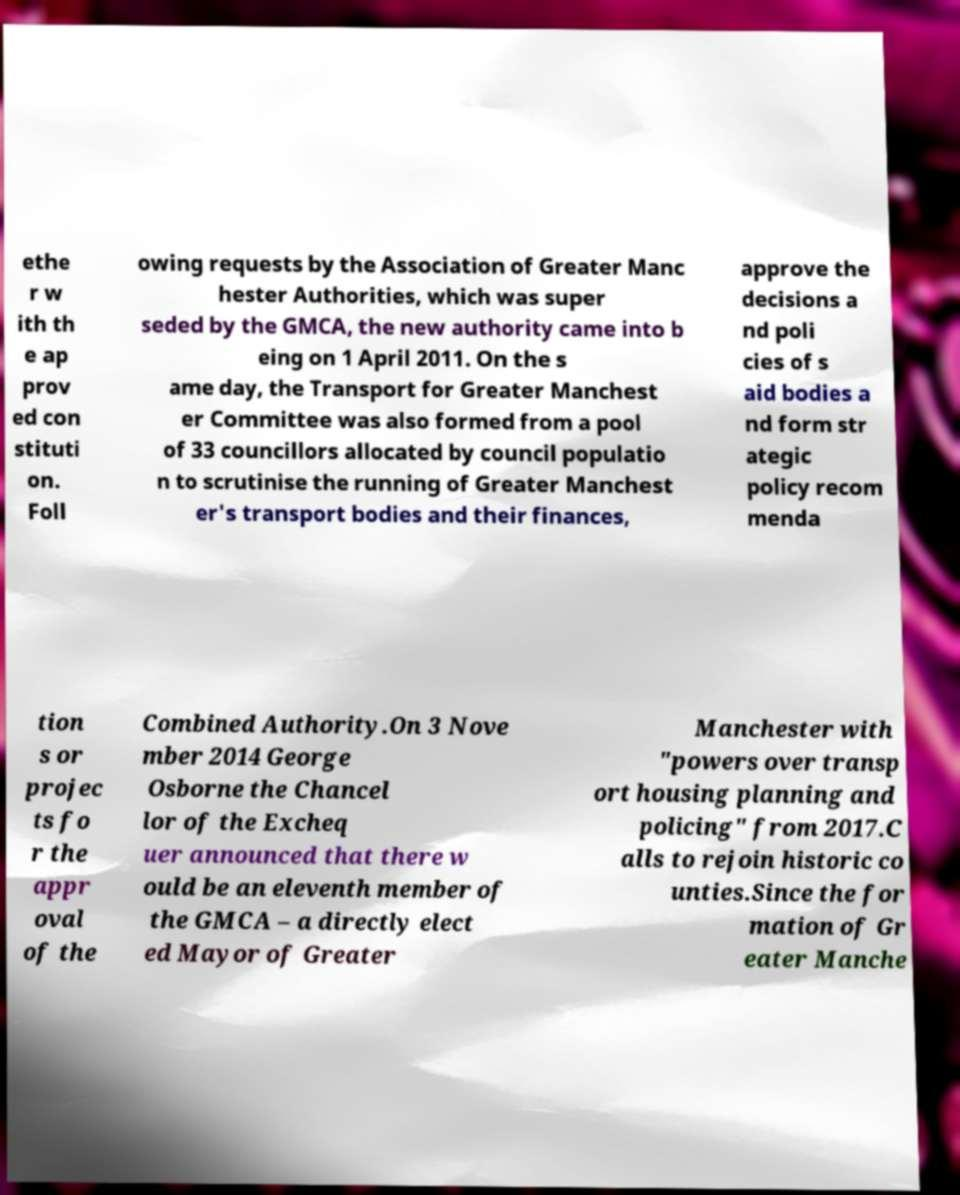For documentation purposes, I need the text within this image transcribed. Could you provide that? ethe r w ith th e ap prov ed con stituti on. Foll owing requests by the Association of Greater Manc hester Authorities, which was super seded by the GMCA, the new authority came into b eing on 1 April 2011. On the s ame day, the Transport for Greater Manchest er Committee was also formed from a pool of 33 councillors allocated by council populatio n to scrutinise the running of Greater Manchest er's transport bodies and their finances, approve the decisions a nd poli cies of s aid bodies a nd form str ategic policy recom menda tion s or projec ts fo r the appr oval of the Combined Authority.On 3 Nove mber 2014 George Osborne the Chancel lor of the Excheq uer announced that there w ould be an eleventh member of the GMCA – a directly elect ed Mayor of Greater Manchester with "powers over transp ort housing planning and policing" from 2017.C alls to rejoin historic co unties.Since the for mation of Gr eater Manche 